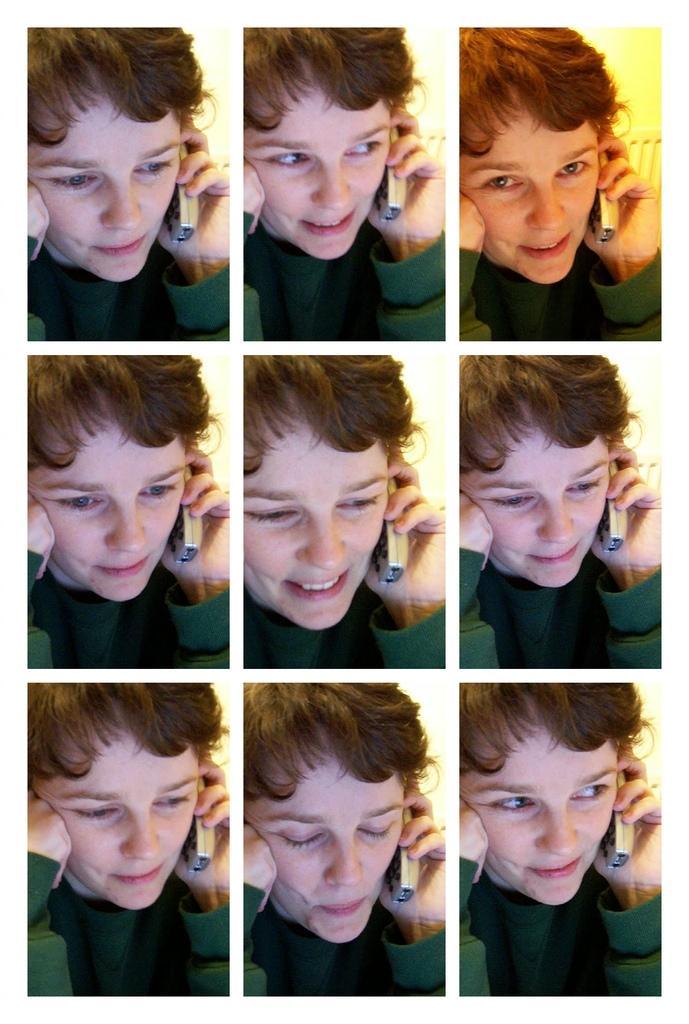Could you give a brief overview of what you see in this image? This is a collage picture,in this picture we can see a person holding a mobile,he is smiling. 